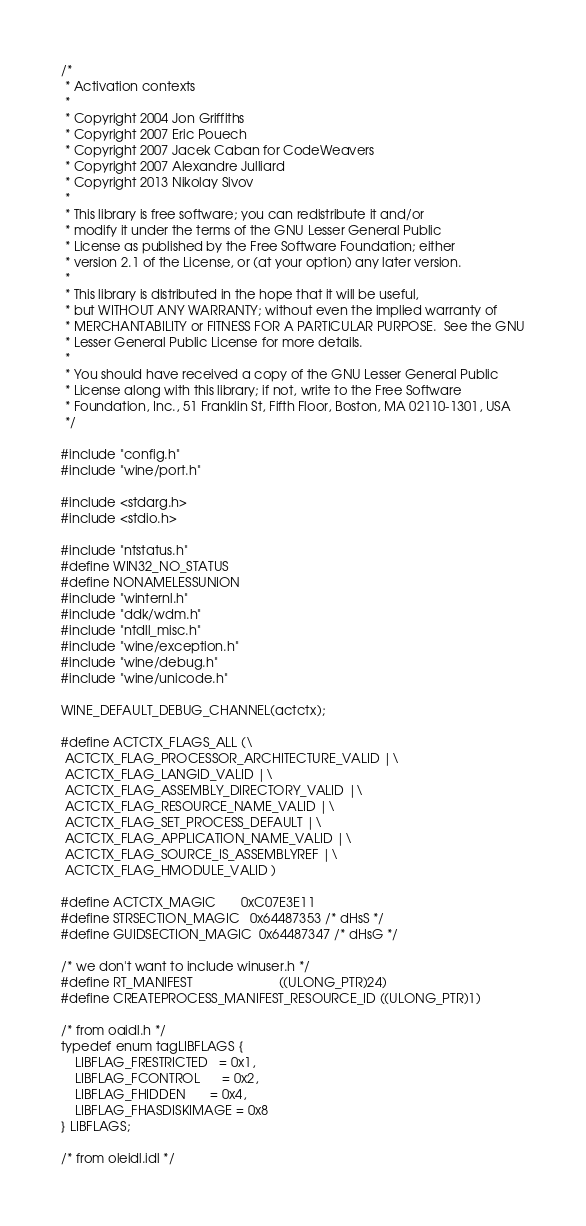<code> <loc_0><loc_0><loc_500><loc_500><_C_>/*
 * Activation contexts
 *
 * Copyright 2004 Jon Griffiths
 * Copyright 2007 Eric Pouech
 * Copyright 2007 Jacek Caban for CodeWeavers
 * Copyright 2007 Alexandre Julliard
 * Copyright 2013 Nikolay Sivov
 *
 * This library is free software; you can redistribute it and/or
 * modify it under the terms of the GNU Lesser General Public
 * License as published by the Free Software Foundation; either
 * version 2.1 of the License, or (at your option) any later version.
 *
 * This library is distributed in the hope that it will be useful,
 * but WITHOUT ANY WARRANTY; without even the implied warranty of
 * MERCHANTABILITY or FITNESS FOR A PARTICULAR PURPOSE.  See the GNU
 * Lesser General Public License for more details.
 *
 * You should have received a copy of the GNU Lesser General Public
 * License along with this library; if not, write to the Free Software
 * Foundation, Inc., 51 Franklin St, Fifth Floor, Boston, MA 02110-1301, USA
 */

#include "config.h"
#include "wine/port.h"

#include <stdarg.h>
#include <stdio.h>

#include "ntstatus.h"
#define WIN32_NO_STATUS
#define NONAMELESSUNION
#include "winternl.h"
#include "ddk/wdm.h"
#include "ntdll_misc.h"
#include "wine/exception.h"
#include "wine/debug.h"
#include "wine/unicode.h"

WINE_DEFAULT_DEBUG_CHANNEL(actctx);

#define ACTCTX_FLAGS_ALL (\
 ACTCTX_FLAG_PROCESSOR_ARCHITECTURE_VALID |\
 ACTCTX_FLAG_LANGID_VALID |\
 ACTCTX_FLAG_ASSEMBLY_DIRECTORY_VALID |\
 ACTCTX_FLAG_RESOURCE_NAME_VALID |\
 ACTCTX_FLAG_SET_PROCESS_DEFAULT |\
 ACTCTX_FLAG_APPLICATION_NAME_VALID |\
 ACTCTX_FLAG_SOURCE_IS_ASSEMBLYREF |\
 ACTCTX_FLAG_HMODULE_VALID )

#define ACTCTX_MAGIC       0xC07E3E11
#define STRSECTION_MAGIC   0x64487353 /* dHsS */
#define GUIDSECTION_MAGIC  0x64487347 /* dHsG */

/* we don't want to include winuser.h */
#define RT_MANIFEST                        ((ULONG_PTR)24)
#define CREATEPROCESS_MANIFEST_RESOURCE_ID ((ULONG_PTR)1)

/* from oaidl.h */
typedef enum tagLIBFLAGS {
    LIBFLAG_FRESTRICTED   = 0x1,
    LIBFLAG_FCONTROL      = 0x2,
    LIBFLAG_FHIDDEN       = 0x4,
    LIBFLAG_FHASDISKIMAGE = 0x8
} LIBFLAGS;

/* from oleidl.idl */</code> 